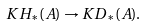Convert formula to latex. <formula><loc_0><loc_0><loc_500><loc_500>K H _ { * } ( A ) \to K D _ { * } ( A ) .</formula> 